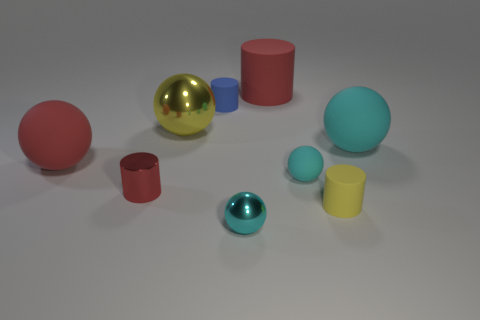Subtract all gray blocks. How many cyan spheres are left? 3 Subtract all red balls. How many balls are left? 4 Subtract all yellow metallic spheres. How many spheres are left? 4 Subtract all blue balls. Subtract all brown cylinders. How many balls are left? 5 Add 1 small metal cylinders. How many objects exist? 10 Subtract all balls. How many objects are left? 4 Subtract 1 blue cylinders. How many objects are left? 8 Subtract all big red blocks. Subtract all tiny yellow matte things. How many objects are left? 8 Add 3 tiny metal spheres. How many tiny metal spheres are left? 4 Add 8 small metal spheres. How many small metal spheres exist? 9 